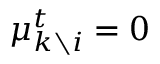<formula> <loc_0><loc_0><loc_500><loc_500>\mu _ { k \ i } ^ { t } = 0</formula> 